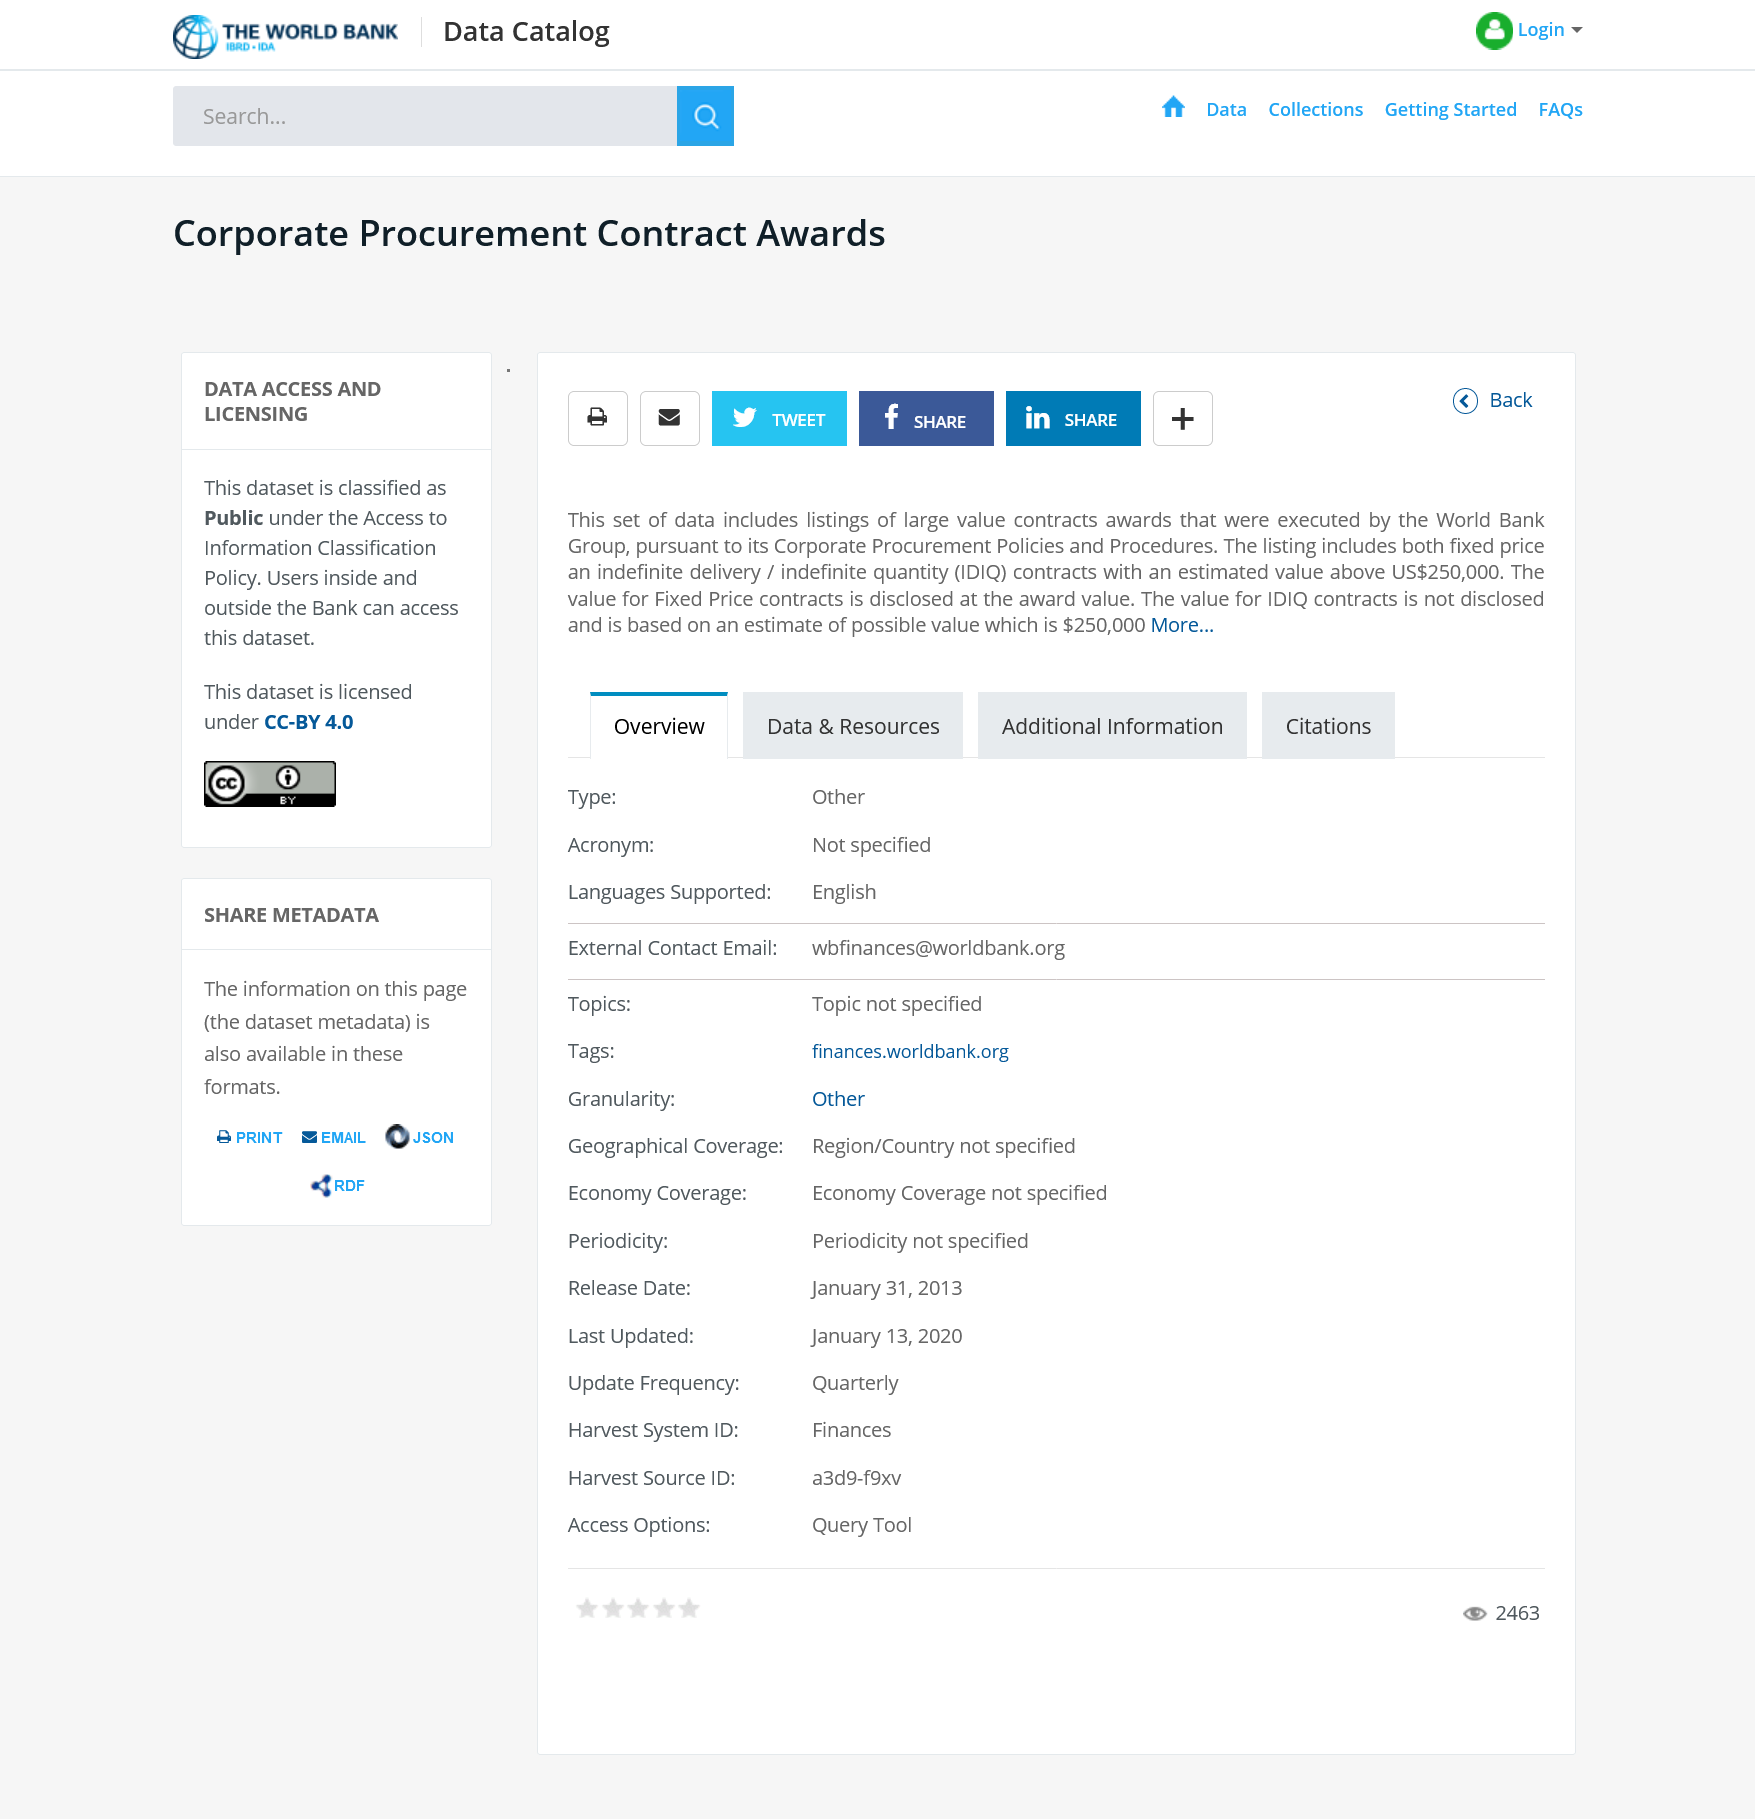Outline some significant characteristics in this image. The possible value of an IDIQ contract can reach up to $250,000. IDIQ stands for indefinite delivery/indefinite quantity, which is a contracting method that allows for the government to purchase goods or services in a flexible and cost-effective manner. 